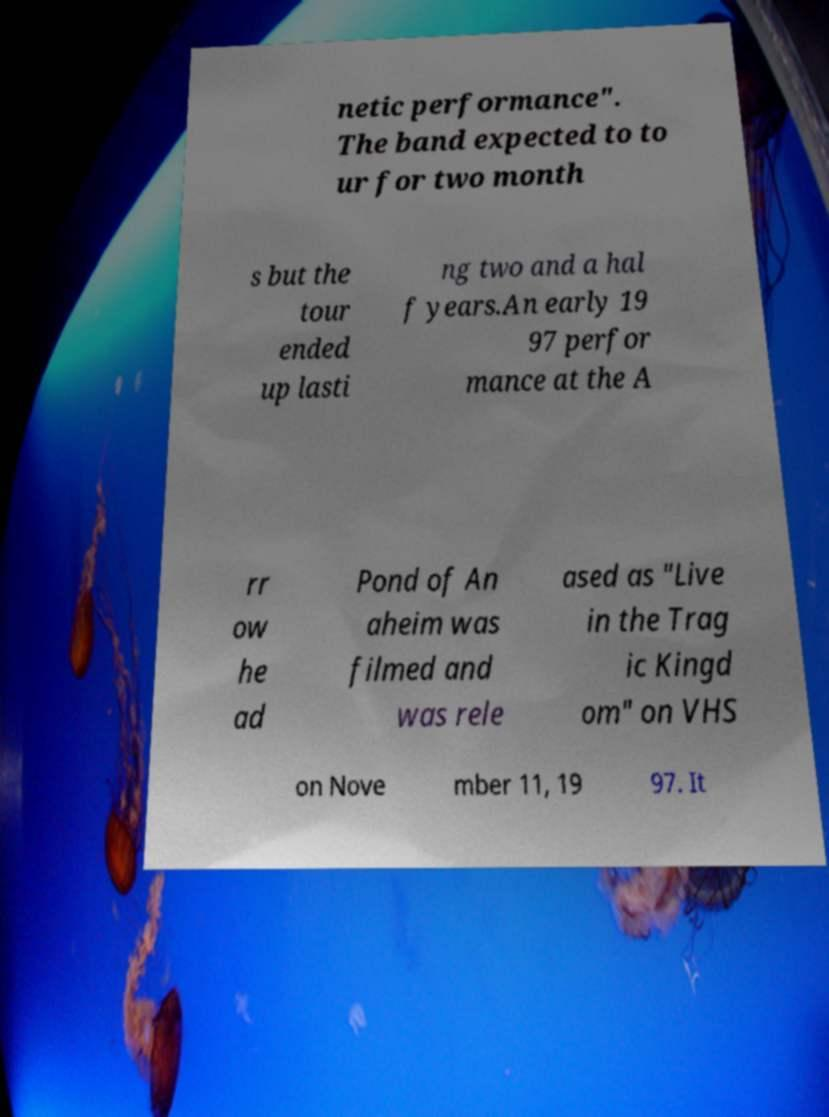What messages or text are displayed in this image? I need them in a readable, typed format. netic performance". The band expected to to ur for two month s but the tour ended up lasti ng two and a hal f years.An early 19 97 perfor mance at the A rr ow he ad Pond of An aheim was filmed and was rele ased as "Live in the Trag ic Kingd om" on VHS on Nove mber 11, 19 97. It 